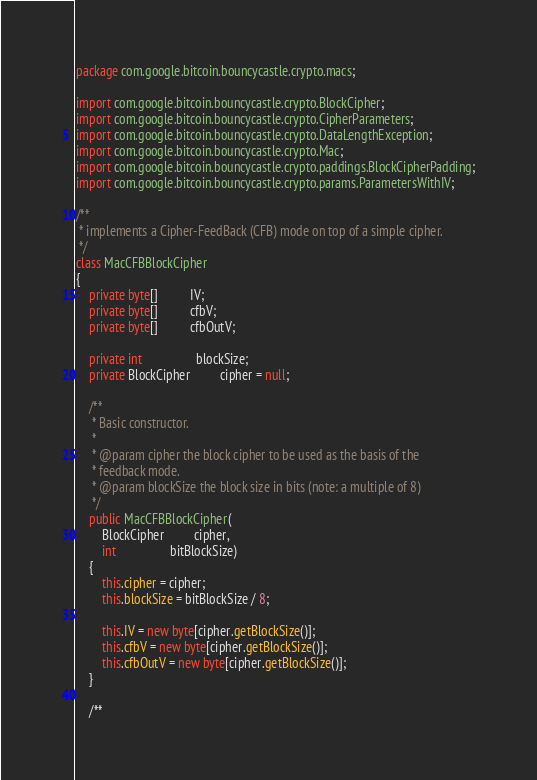<code> <loc_0><loc_0><loc_500><loc_500><_Java_>package com.google.bitcoin.bouncycastle.crypto.macs;

import com.google.bitcoin.bouncycastle.crypto.BlockCipher;
import com.google.bitcoin.bouncycastle.crypto.CipherParameters;
import com.google.bitcoin.bouncycastle.crypto.DataLengthException;
import com.google.bitcoin.bouncycastle.crypto.Mac;
import com.google.bitcoin.bouncycastle.crypto.paddings.BlockCipherPadding;
import com.google.bitcoin.bouncycastle.crypto.params.ParametersWithIV;

/**
 * implements a Cipher-FeedBack (CFB) mode on top of a simple cipher.
 */
class MacCFBBlockCipher
{
    private byte[]          IV;
    private byte[]          cfbV;
    private byte[]          cfbOutV;

    private int                 blockSize;
    private BlockCipher         cipher = null;

    /**
     * Basic constructor.
     *
     * @param cipher the block cipher to be used as the basis of the
     * feedback mode.
     * @param blockSize the block size in bits (note: a multiple of 8)
     */
    public MacCFBBlockCipher(
        BlockCipher         cipher,
        int                 bitBlockSize)
    {
        this.cipher = cipher;
        this.blockSize = bitBlockSize / 8;

        this.IV = new byte[cipher.getBlockSize()];
        this.cfbV = new byte[cipher.getBlockSize()];
        this.cfbOutV = new byte[cipher.getBlockSize()];
    }

    /**</code> 